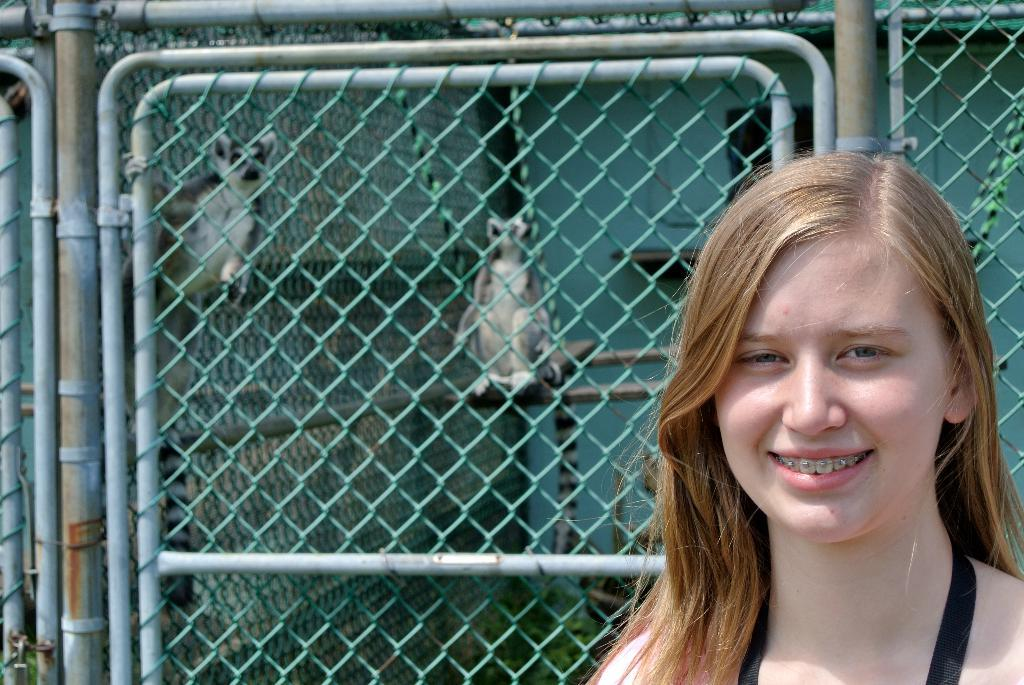Who is present in the image? There is a woman in the image. What can be seen in the background of the image? There is a metal fence and a wall in the image. What is located near the fence in the image? There are animals beside the fence in the image. What type of comb is being used to groom the animals in the image? There is no comb present in the image, and the animals are not being groomed. 